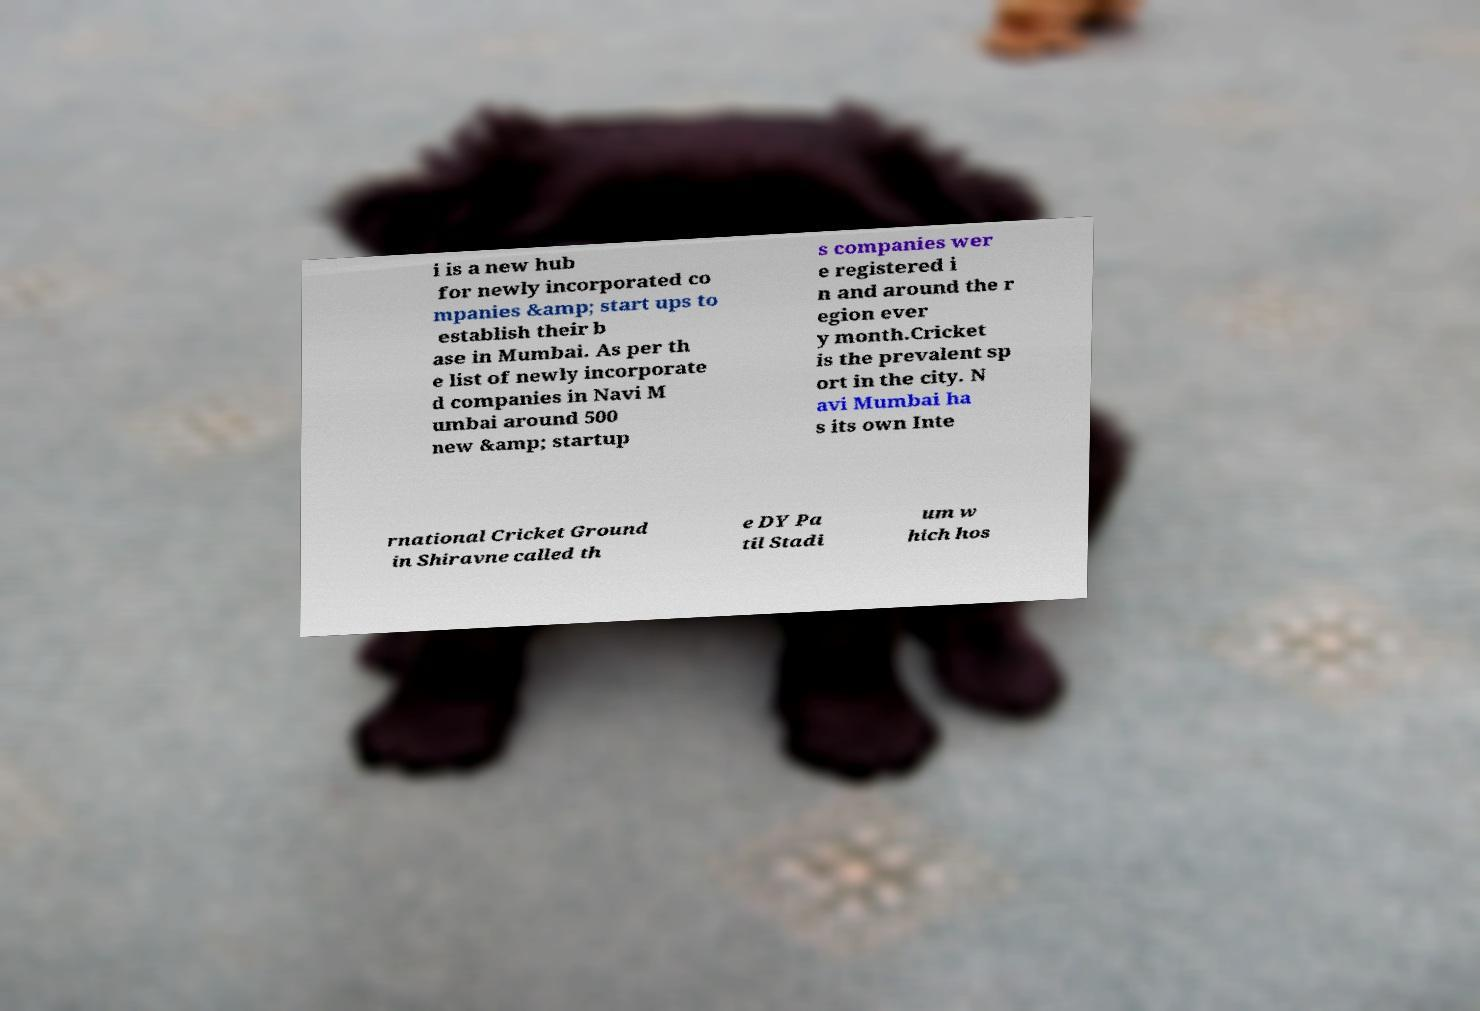What messages or text are displayed in this image? I need them in a readable, typed format. i is a new hub for newly incorporated co mpanies &amp; start ups to establish their b ase in Mumbai. As per th e list of newly incorporate d companies in Navi M umbai around 500 new &amp; startup s companies wer e registered i n and around the r egion ever y month.Cricket is the prevalent sp ort in the city. N avi Mumbai ha s its own Inte rnational Cricket Ground in Shiravne called th e DY Pa til Stadi um w hich hos 